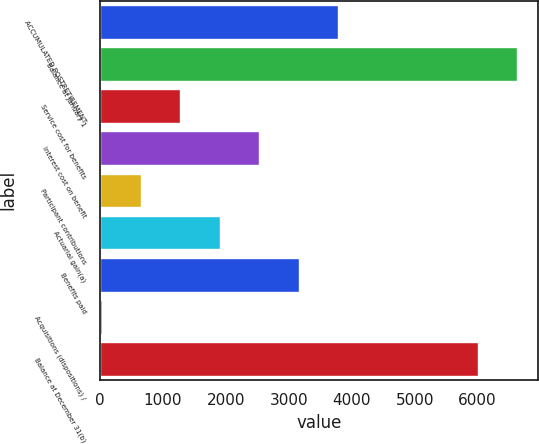Convert chart to OTSL. <chart><loc_0><loc_0><loc_500><loc_500><bar_chart><fcel>ACCUMULATED POSTRETIREMENT<fcel>Balance at January 1<fcel>Service cost for benefits<fcel>Interest cost on benefit<fcel>Participant contributions<fcel>Actuarial gain(a)<fcel>Benefits paid<fcel>Acquisitions (dispositions) /<fcel>Balance at December 31(b)<nl><fcel>3784.2<fcel>6632.2<fcel>1279.4<fcel>2531.8<fcel>653.2<fcel>1905.6<fcel>3158<fcel>27<fcel>6006<nl></chart> 